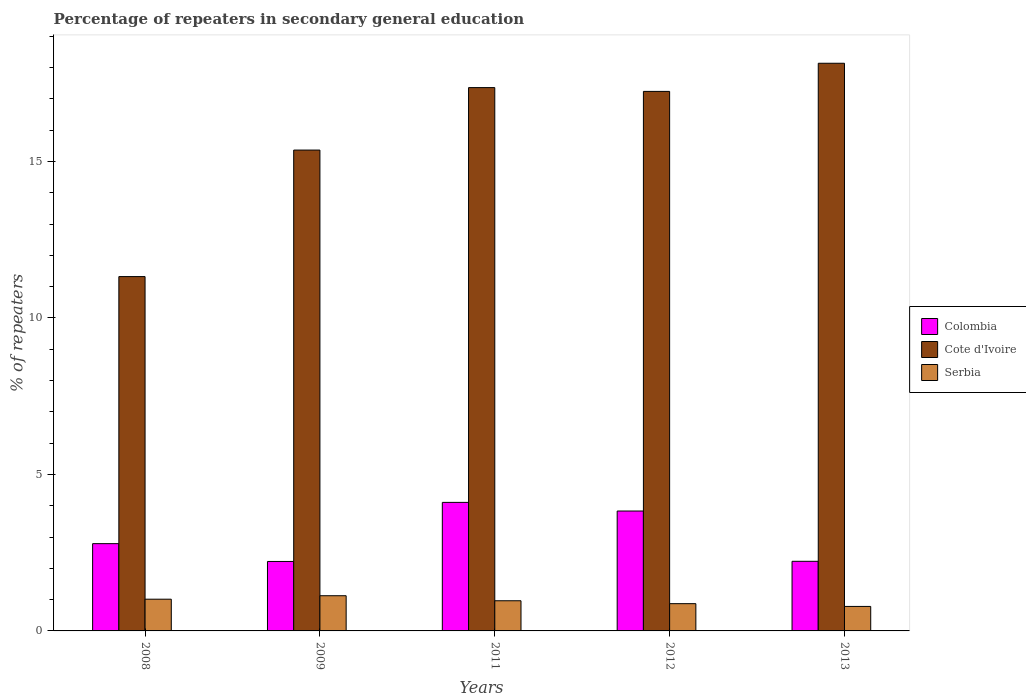How many different coloured bars are there?
Your answer should be compact. 3. How many groups of bars are there?
Make the answer very short. 5. Are the number of bars per tick equal to the number of legend labels?
Ensure brevity in your answer.  Yes. How many bars are there on the 3rd tick from the left?
Keep it short and to the point. 3. How many bars are there on the 3rd tick from the right?
Ensure brevity in your answer.  3. In how many cases, is the number of bars for a given year not equal to the number of legend labels?
Offer a very short reply. 0. What is the percentage of repeaters in secondary general education in Serbia in 2009?
Your answer should be very brief. 1.12. Across all years, what is the maximum percentage of repeaters in secondary general education in Serbia?
Give a very brief answer. 1.12. Across all years, what is the minimum percentage of repeaters in secondary general education in Serbia?
Offer a terse response. 0.78. In which year was the percentage of repeaters in secondary general education in Serbia maximum?
Ensure brevity in your answer.  2009. What is the total percentage of repeaters in secondary general education in Serbia in the graph?
Your answer should be compact. 4.76. What is the difference between the percentage of repeaters in secondary general education in Serbia in 2009 and that in 2012?
Make the answer very short. 0.25. What is the difference between the percentage of repeaters in secondary general education in Serbia in 2011 and the percentage of repeaters in secondary general education in Cote d'Ivoire in 2013?
Your response must be concise. -17.17. What is the average percentage of repeaters in secondary general education in Cote d'Ivoire per year?
Offer a very short reply. 15.89. In the year 2008, what is the difference between the percentage of repeaters in secondary general education in Colombia and percentage of repeaters in secondary general education in Serbia?
Offer a terse response. 1.77. In how many years, is the percentage of repeaters in secondary general education in Colombia greater than 7 %?
Ensure brevity in your answer.  0. What is the ratio of the percentage of repeaters in secondary general education in Cote d'Ivoire in 2009 to that in 2013?
Your answer should be compact. 0.85. What is the difference between the highest and the second highest percentage of repeaters in secondary general education in Cote d'Ivoire?
Your response must be concise. 0.78. What is the difference between the highest and the lowest percentage of repeaters in secondary general education in Colombia?
Your answer should be compact. 1.89. Is the sum of the percentage of repeaters in secondary general education in Serbia in 2009 and 2013 greater than the maximum percentage of repeaters in secondary general education in Cote d'Ivoire across all years?
Give a very brief answer. No. What does the 2nd bar from the left in 2009 represents?
Ensure brevity in your answer.  Cote d'Ivoire. What does the 2nd bar from the right in 2012 represents?
Keep it short and to the point. Cote d'Ivoire. Is it the case that in every year, the sum of the percentage of repeaters in secondary general education in Cote d'Ivoire and percentage of repeaters in secondary general education in Colombia is greater than the percentage of repeaters in secondary general education in Serbia?
Ensure brevity in your answer.  Yes. What is the difference between two consecutive major ticks on the Y-axis?
Your answer should be very brief. 5. Does the graph contain grids?
Give a very brief answer. No. How are the legend labels stacked?
Provide a short and direct response. Vertical. What is the title of the graph?
Make the answer very short. Percentage of repeaters in secondary general education. Does "Denmark" appear as one of the legend labels in the graph?
Offer a very short reply. No. What is the label or title of the Y-axis?
Provide a succinct answer. % of repeaters. What is the % of repeaters of Colombia in 2008?
Give a very brief answer. 2.79. What is the % of repeaters of Cote d'Ivoire in 2008?
Provide a short and direct response. 11.32. What is the % of repeaters in Serbia in 2008?
Your response must be concise. 1.01. What is the % of repeaters in Colombia in 2009?
Offer a very short reply. 2.22. What is the % of repeaters of Cote d'Ivoire in 2009?
Provide a succinct answer. 15.36. What is the % of repeaters of Serbia in 2009?
Give a very brief answer. 1.12. What is the % of repeaters of Colombia in 2011?
Provide a short and direct response. 4.11. What is the % of repeaters in Cote d'Ivoire in 2011?
Make the answer very short. 17.36. What is the % of repeaters of Serbia in 2011?
Offer a very short reply. 0.96. What is the % of repeaters of Colombia in 2012?
Keep it short and to the point. 3.83. What is the % of repeaters of Cote d'Ivoire in 2012?
Provide a succinct answer. 17.24. What is the % of repeaters of Serbia in 2012?
Offer a very short reply. 0.87. What is the % of repeaters of Colombia in 2013?
Ensure brevity in your answer.  2.22. What is the % of repeaters of Cote d'Ivoire in 2013?
Give a very brief answer. 18.14. What is the % of repeaters of Serbia in 2013?
Keep it short and to the point. 0.78. Across all years, what is the maximum % of repeaters of Colombia?
Keep it short and to the point. 4.11. Across all years, what is the maximum % of repeaters in Cote d'Ivoire?
Make the answer very short. 18.14. Across all years, what is the maximum % of repeaters of Serbia?
Your answer should be compact. 1.12. Across all years, what is the minimum % of repeaters in Colombia?
Keep it short and to the point. 2.22. Across all years, what is the minimum % of repeaters in Cote d'Ivoire?
Offer a very short reply. 11.32. Across all years, what is the minimum % of repeaters of Serbia?
Offer a very short reply. 0.78. What is the total % of repeaters in Colombia in the graph?
Provide a succinct answer. 15.17. What is the total % of repeaters of Cote d'Ivoire in the graph?
Keep it short and to the point. 79.43. What is the total % of repeaters of Serbia in the graph?
Make the answer very short. 4.76. What is the difference between the % of repeaters of Colombia in 2008 and that in 2009?
Ensure brevity in your answer.  0.57. What is the difference between the % of repeaters of Cote d'Ivoire in 2008 and that in 2009?
Make the answer very short. -4.04. What is the difference between the % of repeaters of Serbia in 2008 and that in 2009?
Your answer should be very brief. -0.11. What is the difference between the % of repeaters in Colombia in 2008 and that in 2011?
Offer a terse response. -1.32. What is the difference between the % of repeaters in Cote d'Ivoire in 2008 and that in 2011?
Make the answer very short. -6.04. What is the difference between the % of repeaters of Serbia in 2008 and that in 2011?
Your answer should be very brief. 0.05. What is the difference between the % of repeaters in Colombia in 2008 and that in 2012?
Offer a very short reply. -1.04. What is the difference between the % of repeaters in Cote d'Ivoire in 2008 and that in 2012?
Provide a succinct answer. -5.92. What is the difference between the % of repeaters of Serbia in 2008 and that in 2012?
Offer a terse response. 0.14. What is the difference between the % of repeaters in Colombia in 2008 and that in 2013?
Keep it short and to the point. 0.56. What is the difference between the % of repeaters in Cote d'Ivoire in 2008 and that in 2013?
Your answer should be compact. -6.82. What is the difference between the % of repeaters of Serbia in 2008 and that in 2013?
Keep it short and to the point. 0.23. What is the difference between the % of repeaters of Colombia in 2009 and that in 2011?
Offer a very short reply. -1.89. What is the difference between the % of repeaters of Cote d'Ivoire in 2009 and that in 2011?
Your answer should be compact. -2. What is the difference between the % of repeaters in Serbia in 2009 and that in 2011?
Ensure brevity in your answer.  0.16. What is the difference between the % of repeaters of Colombia in 2009 and that in 2012?
Provide a short and direct response. -1.61. What is the difference between the % of repeaters in Cote d'Ivoire in 2009 and that in 2012?
Keep it short and to the point. -1.87. What is the difference between the % of repeaters in Serbia in 2009 and that in 2012?
Keep it short and to the point. 0.25. What is the difference between the % of repeaters of Colombia in 2009 and that in 2013?
Offer a very short reply. -0.01. What is the difference between the % of repeaters in Cote d'Ivoire in 2009 and that in 2013?
Make the answer very short. -2.77. What is the difference between the % of repeaters in Serbia in 2009 and that in 2013?
Provide a succinct answer. 0.34. What is the difference between the % of repeaters of Colombia in 2011 and that in 2012?
Give a very brief answer. 0.28. What is the difference between the % of repeaters in Cote d'Ivoire in 2011 and that in 2012?
Keep it short and to the point. 0.12. What is the difference between the % of repeaters of Serbia in 2011 and that in 2012?
Your answer should be very brief. 0.09. What is the difference between the % of repeaters of Colombia in 2011 and that in 2013?
Provide a succinct answer. 1.88. What is the difference between the % of repeaters of Cote d'Ivoire in 2011 and that in 2013?
Your response must be concise. -0.78. What is the difference between the % of repeaters in Serbia in 2011 and that in 2013?
Your answer should be compact. 0.18. What is the difference between the % of repeaters in Colombia in 2012 and that in 2013?
Your response must be concise. 1.61. What is the difference between the % of repeaters of Cote d'Ivoire in 2012 and that in 2013?
Offer a very short reply. -0.9. What is the difference between the % of repeaters in Serbia in 2012 and that in 2013?
Provide a short and direct response. 0.09. What is the difference between the % of repeaters in Colombia in 2008 and the % of repeaters in Cote d'Ivoire in 2009?
Your answer should be compact. -12.58. What is the difference between the % of repeaters of Colombia in 2008 and the % of repeaters of Serbia in 2009?
Keep it short and to the point. 1.66. What is the difference between the % of repeaters of Cote d'Ivoire in 2008 and the % of repeaters of Serbia in 2009?
Your answer should be compact. 10.2. What is the difference between the % of repeaters in Colombia in 2008 and the % of repeaters in Cote d'Ivoire in 2011?
Ensure brevity in your answer.  -14.57. What is the difference between the % of repeaters of Colombia in 2008 and the % of repeaters of Serbia in 2011?
Your answer should be compact. 1.82. What is the difference between the % of repeaters in Cote d'Ivoire in 2008 and the % of repeaters in Serbia in 2011?
Offer a very short reply. 10.36. What is the difference between the % of repeaters of Colombia in 2008 and the % of repeaters of Cote d'Ivoire in 2012?
Provide a succinct answer. -14.45. What is the difference between the % of repeaters of Colombia in 2008 and the % of repeaters of Serbia in 2012?
Offer a terse response. 1.92. What is the difference between the % of repeaters in Cote d'Ivoire in 2008 and the % of repeaters in Serbia in 2012?
Provide a short and direct response. 10.45. What is the difference between the % of repeaters of Colombia in 2008 and the % of repeaters of Cote d'Ivoire in 2013?
Provide a succinct answer. -15.35. What is the difference between the % of repeaters in Colombia in 2008 and the % of repeaters in Serbia in 2013?
Your answer should be very brief. 2.01. What is the difference between the % of repeaters of Cote d'Ivoire in 2008 and the % of repeaters of Serbia in 2013?
Offer a terse response. 10.54. What is the difference between the % of repeaters of Colombia in 2009 and the % of repeaters of Cote d'Ivoire in 2011?
Keep it short and to the point. -15.14. What is the difference between the % of repeaters of Colombia in 2009 and the % of repeaters of Serbia in 2011?
Keep it short and to the point. 1.26. What is the difference between the % of repeaters in Cote d'Ivoire in 2009 and the % of repeaters in Serbia in 2011?
Offer a terse response. 14.4. What is the difference between the % of repeaters in Colombia in 2009 and the % of repeaters in Cote d'Ivoire in 2012?
Provide a succinct answer. -15.02. What is the difference between the % of repeaters in Colombia in 2009 and the % of repeaters in Serbia in 2012?
Give a very brief answer. 1.35. What is the difference between the % of repeaters of Cote d'Ivoire in 2009 and the % of repeaters of Serbia in 2012?
Make the answer very short. 14.49. What is the difference between the % of repeaters in Colombia in 2009 and the % of repeaters in Cote d'Ivoire in 2013?
Provide a short and direct response. -15.92. What is the difference between the % of repeaters of Colombia in 2009 and the % of repeaters of Serbia in 2013?
Give a very brief answer. 1.44. What is the difference between the % of repeaters in Cote d'Ivoire in 2009 and the % of repeaters in Serbia in 2013?
Provide a short and direct response. 14.58. What is the difference between the % of repeaters of Colombia in 2011 and the % of repeaters of Cote d'Ivoire in 2012?
Provide a succinct answer. -13.13. What is the difference between the % of repeaters of Colombia in 2011 and the % of repeaters of Serbia in 2012?
Provide a short and direct response. 3.24. What is the difference between the % of repeaters of Cote d'Ivoire in 2011 and the % of repeaters of Serbia in 2012?
Ensure brevity in your answer.  16.49. What is the difference between the % of repeaters of Colombia in 2011 and the % of repeaters of Cote d'Ivoire in 2013?
Your answer should be very brief. -14.03. What is the difference between the % of repeaters in Colombia in 2011 and the % of repeaters in Serbia in 2013?
Provide a succinct answer. 3.32. What is the difference between the % of repeaters of Cote d'Ivoire in 2011 and the % of repeaters of Serbia in 2013?
Make the answer very short. 16.58. What is the difference between the % of repeaters in Colombia in 2012 and the % of repeaters in Cote d'Ivoire in 2013?
Your answer should be compact. -14.31. What is the difference between the % of repeaters in Colombia in 2012 and the % of repeaters in Serbia in 2013?
Ensure brevity in your answer.  3.05. What is the difference between the % of repeaters of Cote d'Ivoire in 2012 and the % of repeaters of Serbia in 2013?
Offer a very short reply. 16.46. What is the average % of repeaters in Colombia per year?
Ensure brevity in your answer.  3.03. What is the average % of repeaters of Cote d'Ivoire per year?
Your answer should be very brief. 15.89. What is the average % of repeaters of Serbia per year?
Your answer should be very brief. 0.95. In the year 2008, what is the difference between the % of repeaters of Colombia and % of repeaters of Cote d'Ivoire?
Give a very brief answer. -8.53. In the year 2008, what is the difference between the % of repeaters of Colombia and % of repeaters of Serbia?
Your response must be concise. 1.77. In the year 2008, what is the difference between the % of repeaters in Cote d'Ivoire and % of repeaters in Serbia?
Your response must be concise. 10.31. In the year 2009, what is the difference between the % of repeaters in Colombia and % of repeaters in Cote d'Ivoire?
Give a very brief answer. -13.15. In the year 2009, what is the difference between the % of repeaters in Colombia and % of repeaters in Serbia?
Offer a terse response. 1.09. In the year 2009, what is the difference between the % of repeaters of Cote d'Ivoire and % of repeaters of Serbia?
Offer a terse response. 14.24. In the year 2011, what is the difference between the % of repeaters of Colombia and % of repeaters of Cote d'Ivoire?
Provide a succinct answer. -13.25. In the year 2011, what is the difference between the % of repeaters of Colombia and % of repeaters of Serbia?
Make the answer very short. 3.14. In the year 2011, what is the difference between the % of repeaters in Cote d'Ivoire and % of repeaters in Serbia?
Offer a very short reply. 16.4. In the year 2012, what is the difference between the % of repeaters in Colombia and % of repeaters in Cote d'Ivoire?
Keep it short and to the point. -13.41. In the year 2012, what is the difference between the % of repeaters in Colombia and % of repeaters in Serbia?
Your answer should be very brief. 2.96. In the year 2012, what is the difference between the % of repeaters in Cote d'Ivoire and % of repeaters in Serbia?
Provide a short and direct response. 16.37. In the year 2013, what is the difference between the % of repeaters in Colombia and % of repeaters in Cote d'Ivoire?
Ensure brevity in your answer.  -15.91. In the year 2013, what is the difference between the % of repeaters in Colombia and % of repeaters in Serbia?
Your answer should be compact. 1.44. In the year 2013, what is the difference between the % of repeaters of Cote d'Ivoire and % of repeaters of Serbia?
Make the answer very short. 17.36. What is the ratio of the % of repeaters of Colombia in 2008 to that in 2009?
Your response must be concise. 1.26. What is the ratio of the % of repeaters in Cote d'Ivoire in 2008 to that in 2009?
Offer a very short reply. 0.74. What is the ratio of the % of repeaters in Serbia in 2008 to that in 2009?
Your answer should be compact. 0.9. What is the ratio of the % of repeaters of Colombia in 2008 to that in 2011?
Offer a terse response. 0.68. What is the ratio of the % of repeaters in Cote d'Ivoire in 2008 to that in 2011?
Make the answer very short. 0.65. What is the ratio of the % of repeaters of Serbia in 2008 to that in 2011?
Provide a short and direct response. 1.05. What is the ratio of the % of repeaters in Colombia in 2008 to that in 2012?
Offer a terse response. 0.73. What is the ratio of the % of repeaters in Cote d'Ivoire in 2008 to that in 2012?
Your response must be concise. 0.66. What is the ratio of the % of repeaters in Serbia in 2008 to that in 2012?
Your answer should be very brief. 1.16. What is the ratio of the % of repeaters of Colombia in 2008 to that in 2013?
Your answer should be very brief. 1.25. What is the ratio of the % of repeaters in Cote d'Ivoire in 2008 to that in 2013?
Keep it short and to the point. 0.62. What is the ratio of the % of repeaters in Serbia in 2008 to that in 2013?
Provide a short and direct response. 1.3. What is the ratio of the % of repeaters of Colombia in 2009 to that in 2011?
Provide a short and direct response. 0.54. What is the ratio of the % of repeaters of Cote d'Ivoire in 2009 to that in 2011?
Offer a very short reply. 0.89. What is the ratio of the % of repeaters in Serbia in 2009 to that in 2011?
Offer a terse response. 1.17. What is the ratio of the % of repeaters in Colombia in 2009 to that in 2012?
Offer a very short reply. 0.58. What is the ratio of the % of repeaters in Cote d'Ivoire in 2009 to that in 2012?
Your response must be concise. 0.89. What is the ratio of the % of repeaters of Serbia in 2009 to that in 2012?
Provide a succinct answer. 1.29. What is the ratio of the % of repeaters of Colombia in 2009 to that in 2013?
Make the answer very short. 1. What is the ratio of the % of repeaters in Cote d'Ivoire in 2009 to that in 2013?
Keep it short and to the point. 0.85. What is the ratio of the % of repeaters in Serbia in 2009 to that in 2013?
Your answer should be very brief. 1.44. What is the ratio of the % of repeaters of Colombia in 2011 to that in 2012?
Make the answer very short. 1.07. What is the ratio of the % of repeaters of Serbia in 2011 to that in 2012?
Make the answer very short. 1.11. What is the ratio of the % of repeaters in Colombia in 2011 to that in 2013?
Provide a short and direct response. 1.85. What is the ratio of the % of repeaters in Cote d'Ivoire in 2011 to that in 2013?
Offer a very short reply. 0.96. What is the ratio of the % of repeaters of Serbia in 2011 to that in 2013?
Give a very brief answer. 1.23. What is the ratio of the % of repeaters of Colombia in 2012 to that in 2013?
Offer a very short reply. 1.72. What is the ratio of the % of repeaters in Cote d'Ivoire in 2012 to that in 2013?
Provide a succinct answer. 0.95. What is the ratio of the % of repeaters of Serbia in 2012 to that in 2013?
Your response must be concise. 1.11. What is the difference between the highest and the second highest % of repeaters of Colombia?
Your answer should be compact. 0.28. What is the difference between the highest and the second highest % of repeaters of Cote d'Ivoire?
Keep it short and to the point. 0.78. What is the difference between the highest and the second highest % of repeaters in Serbia?
Give a very brief answer. 0.11. What is the difference between the highest and the lowest % of repeaters of Colombia?
Your response must be concise. 1.89. What is the difference between the highest and the lowest % of repeaters in Cote d'Ivoire?
Provide a succinct answer. 6.82. What is the difference between the highest and the lowest % of repeaters in Serbia?
Give a very brief answer. 0.34. 